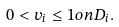Convert formula to latex. <formula><loc_0><loc_0><loc_500><loc_500>0 < v _ { i } \leq 1 o n D _ { i } .</formula> 